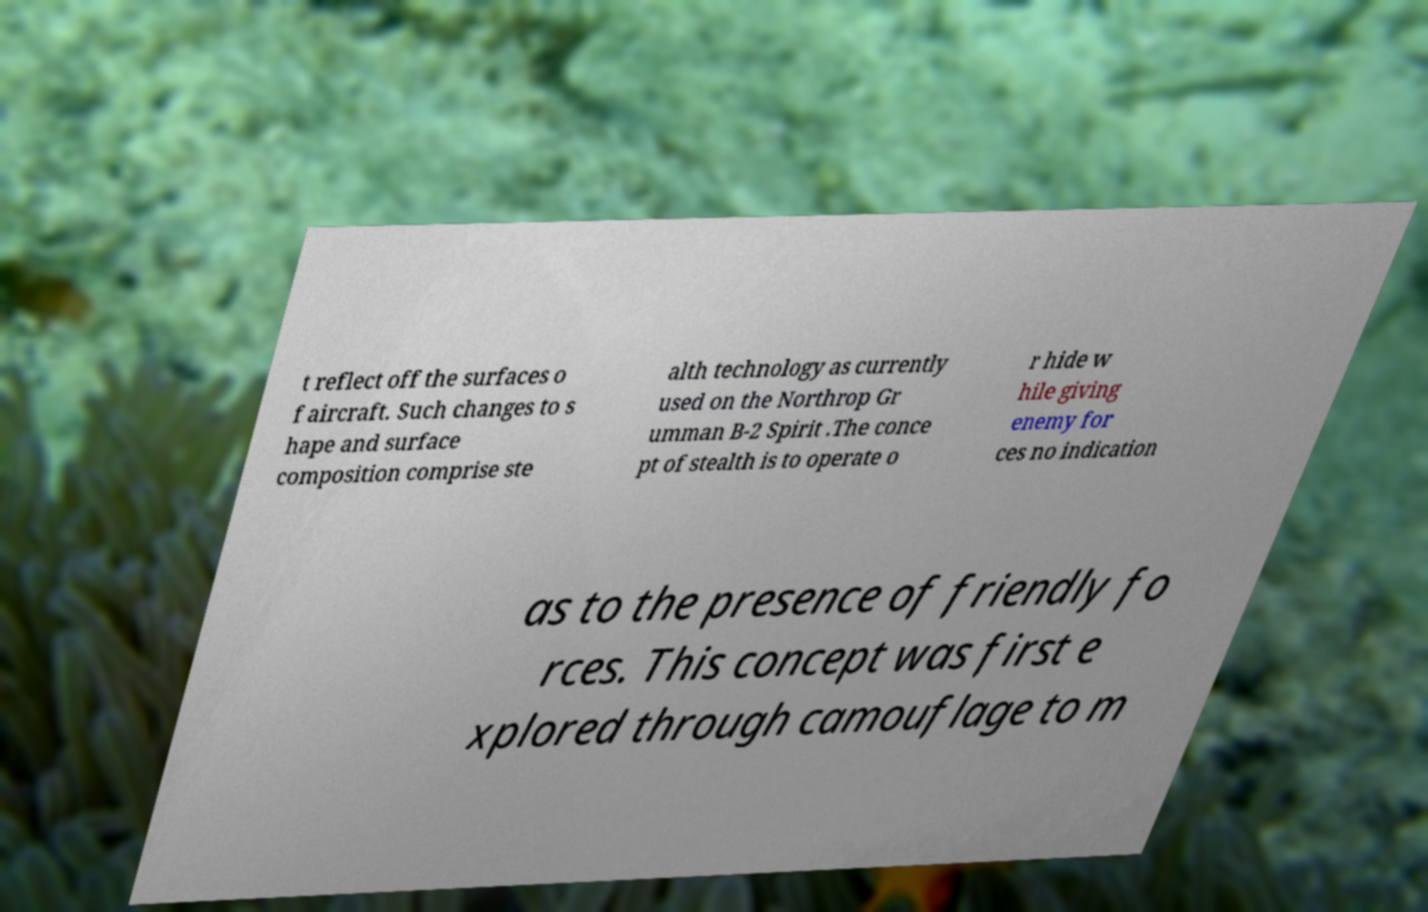Please identify and transcribe the text found in this image. t reflect off the surfaces o f aircraft. Such changes to s hape and surface composition comprise ste alth technology as currently used on the Northrop Gr umman B-2 Spirit .The conce pt of stealth is to operate o r hide w hile giving enemy for ces no indication as to the presence of friendly fo rces. This concept was first e xplored through camouflage to m 